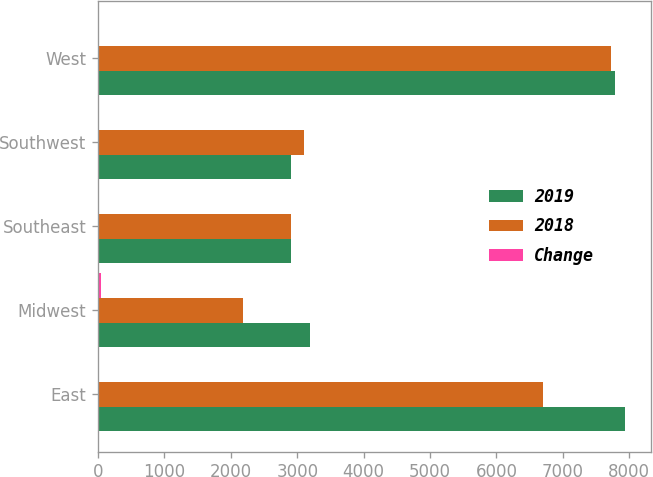Convert chart. <chart><loc_0><loc_0><loc_500><loc_500><stacked_bar_chart><ecel><fcel>East<fcel>Midwest<fcel>Southeast<fcel>Southwest<fcel>West<nl><fcel>2019<fcel>7928<fcel>3193<fcel>2910<fcel>2910<fcel>7787<nl><fcel>2018<fcel>6697<fcel>2186<fcel>2910<fcel>3094<fcel>7724<nl><fcel>Change<fcel>18<fcel>46<fcel>8<fcel>6<fcel>1<nl></chart> 